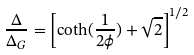<formula> <loc_0><loc_0><loc_500><loc_500>\frac { \Delta } { \Delta _ { G } } = \left [ \coth ( \frac { 1 } { 2 \phi } ) + \sqrt { 2 } \right ] ^ { 1 / 2 }</formula> 